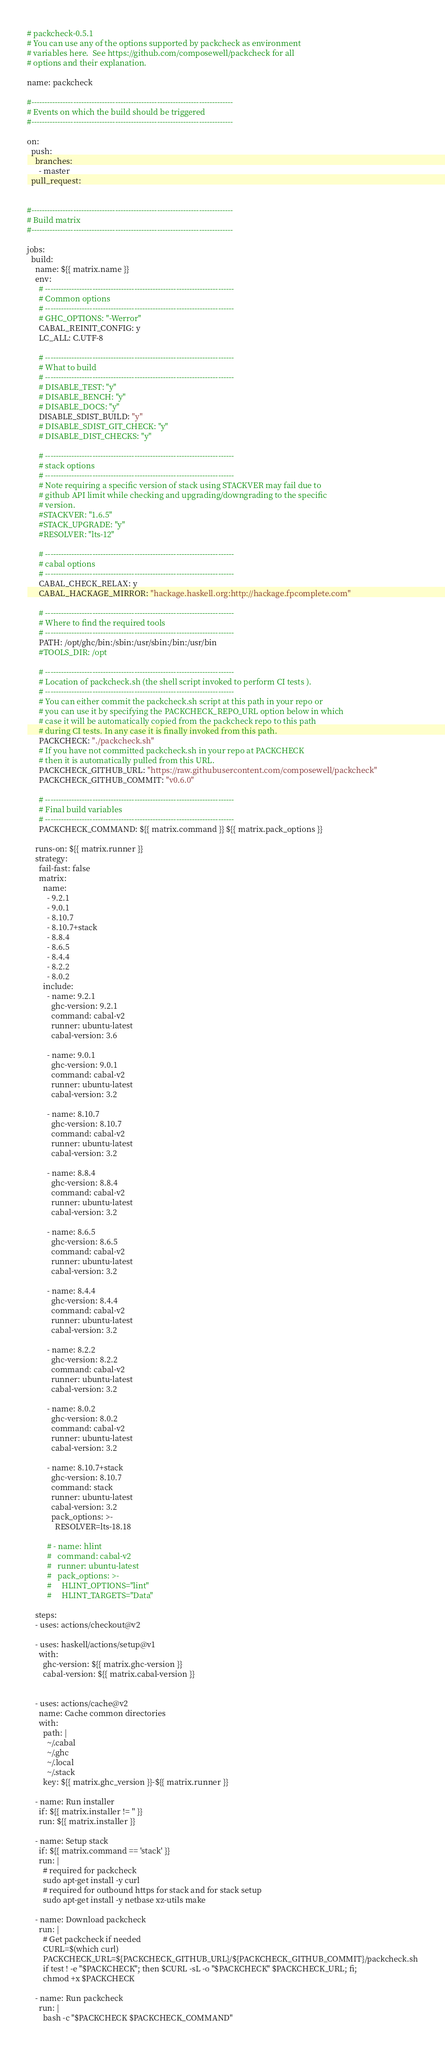<code> <loc_0><loc_0><loc_500><loc_500><_YAML_># packcheck-0.5.1
# You can use any of the options supported by packcheck as environment
# variables here.  See https://github.com/composewell/packcheck for all
# options and their explanation.

name: packcheck

#-----------------------------------------------------------------------------
# Events on which the build should be triggered
#-----------------------------------------------------------------------------

on:
  push:
    branches:
      - master
  pull_request:


#-----------------------------------------------------------------------------
# Build matrix
#-----------------------------------------------------------------------------

jobs:
  build:
    name: ${{ matrix.name }}
    env:
      # ------------------------------------------------------------------------
      # Common options
      # ------------------------------------------------------------------------
      # GHC_OPTIONS: "-Werror"
      CABAL_REINIT_CONFIG: y
      LC_ALL: C.UTF-8

      # ------------------------------------------------------------------------
      # What to build
      # ------------------------------------------------------------------------
      # DISABLE_TEST: "y"
      # DISABLE_BENCH: "y"
      # DISABLE_DOCS: "y"
      DISABLE_SDIST_BUILD: "y"
      # DISABLE_SDIST_GIT_CHECK: "y"
      # DISABLE_DIST_CHECKS: "y"

      # ------------------------------------------------------------------------
      # stack options
      # ------------------------------------------------------------------------
      # Note requiring a specific version of stack using STACKVER may fail due to
      # github API limit while checking and upgrading/downgrading to the specific
      # version.
      #STACKVER: "1.6.5"
      #STACK_UPGRADE: "y"
      #RESOLVER: "lts-12"

      # ------------------------------------------------------------------------
      # cabal options
      # ------------------------------------------------------------------------
      CABAL_CHECK_RELAX: y
      CABAL_HACKAGE_MIRROR: "hackage.haskell.org:http://hackage.fpcomplete.com"

      # ------------------------------------------------------------------------
      # Where to find the required tools
      # ------------------------------------------------------------------------
      PATH: /opt/ghc/bin:/sbin:/usr/sbin:/bin:/usr/bin
      #TOOLS_DIR: /opt

      # ------------------------------------------------------------------------
      # Location of packcheck.sh (the shell script invoked to perform CI tests ).
      # ------------------------------------------------------------------------
      # You can either commit the packcheck.sh script at this path in your repo or
      # you can use it by specifying the PACKCHECK_REPO_URL option below in which
      # case it will be automatically copied from the packcheck repo to this path
      # during CI tests. In any case it is finally invoked from this path.
      PACKCHECK: "./packcheck.sh"
      # If you have not committed packcheck.sh in your repo at PACKCHECK
      # then it is automatically pulled from this URL.
      PACKCHECK_GITHUB_URL: "https://raw.githubusercontent.com/composewell/packcheck"
      PACKCHECK_GITHUB_COMMIT: "v0.6.0"

      # ------------------------------------------------------------------------
      # Final build variables
      # ------------------------------------------------------------------------
      PACKCHECK_COMMAND: ${{ matrix.command }} ${{ matrix.pack_options }}

    runs-on: ${{ matrix.runner }}
    strategy:
      fail-fast: false
      matrix:
        name:
          - 9.2.1
          - 9.0.1
          - 8.10.7
          - 8.10.7+stack
          - 8.8.4
          - 8.6.5
          - 8.4.4
          - 8.2.2
          - 8.0.2
        include:
          - name: 9.2.1
            ghc-version: 9.2.1
            command: cabal-v2
            runner: ubuntu-latest
            cabal-version: 3.6

          - name: 9.0.1
            ghc-version: 9.0.1
            command: cabal-v2
            runner: ubuntu-latest
            cabal-version: 3.2

          - name: 8.10.7
            ghc-version: 8.10.7
            command: cabal-v2
            runner: ubuntu-latest
            cabal-version: 3.2

          - name: 8.8.4
            ghc-version: 8.8.4
            command: cabal-v2
            runner: ubuntu-latest
            cabal-version: 3.2

          - name: 8.6.5
            ghc-version: 8.6.5
            command: cabal-v2
            runner: ubuntu-latest
            cabal-version: 3.2

          - name: 8.4.4
            ghc-version: 8.4.4
            command: cabal-v2
            runner: ubuntu-latest
            cabal-version: 3.2

          - name: 8.2.2
            ghc-version: 8.2.2
            command: cabal-v2
            runner: ubuntu-latest
            cabal-version: 3.2

          - name: 8.0.2
            ghc-version: 8.0.2
            command: cabal-v2
            runner: ubuntu-latest
            cabal-version: 3.2

          - name: 8.10.7+stack
            ghc-version: 8.10.7
            command: stack
            runner: ubuntu-latest
            cabal-version: 3.2
            pack_options: >-
              RESOLVER=lts-18.18

          # - name: hlint
          #   command: cabal-v2
          #   runner: ubuntu-latest
          #   pack_options: >-
          #     HLINT_OPTIONS="lint"
          #     HLINT_TARGETS="Data"

    steps:
    - uses: actions/checkout@v2

    - uses: haskell/actions/setup@v1
      with:
        ghc-version: ${{ matrix.ghc-version }}
        cabal-version: ${{ matrix.cabal-version }}


    - uses: actions/cache@v2
      name: Cache common directories
      with:
        path: |
          ~/.cabal
          ~/.ghc
          ~/.local
          ~/.stack
        key: ${{ matrix.ghc_version }}-${{ matrix.runner }}

    - name: Run installer
      if: ${{ matrix.installer != '' }}
      run: ${{ matrix.installer }}

    - name: Setup stack
      if: ${{ matrix.command == 'stack' }}
      run: |
        # required for packcheck
        sudo apt-get install -y curl
        # required for outbound https for stack and for stack setup
        sudo apt-get install -y netbase xz-utils make

    - name: Download packcheck
      run: |
        # Get packcheck if needed
        CURL=$(which curl)
        PACKCHECK_URL=${PACKCHECK_GITHUB_URL}/${PACKCHECK_GITHUB_COMMIT}/packcheck.sh
        if test ! -e "$PACKCHECK"; then $CURL -sL -o "$PACKCHECK" $PACKCHECK_URL; fi;
        chmod +x $PACKCHECK

    - name: Run packcheck
      run: |
        bash -c "$PACKCHECK $PACKCHECK_COMMAND"
</code> 